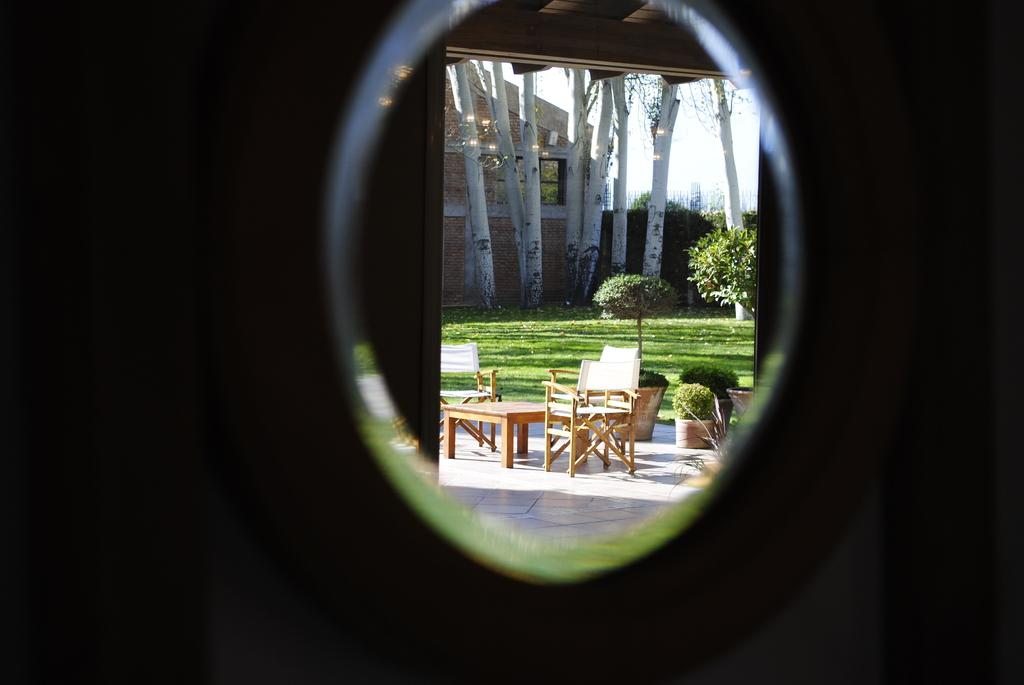What is located in the foreground of the image? There is a window in the foreground of the image. What can be seen in the background of the image? There is a table, chairs, a flower pot, plants, trees, and a house in the background of the image. What type of vegetation is visible in the center of the image? There is grass in the center of the image. What type of line is visible in the image? There is no specific line mentioned or visible in the image. What suggestion can be made based on the presence of the house in the image? The presence of the house in the image does not inherently suggest anything; it is simply an element of the scene. 